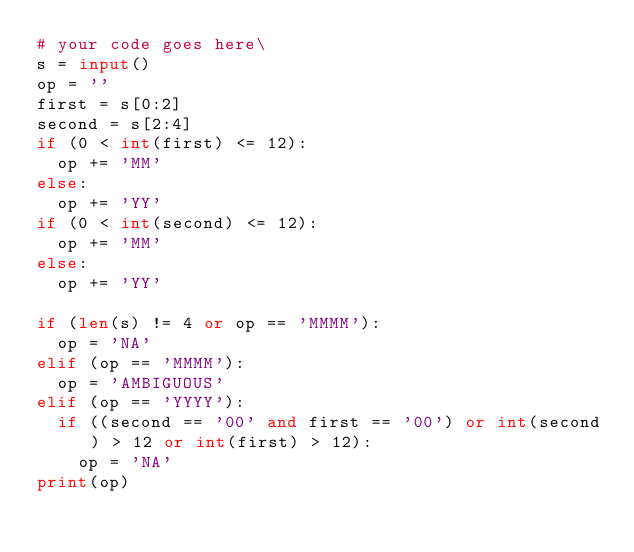Convert code to text. <code><loc_0><loc_0><loc_500><loc_500><_Python_># your code goes here\
s = input()
op = ''
first = s[0:2]
second = s[2:4]
if (0 < int(first) <= 12):
	op += 'MM'
else:
	op += 'YY'
if (0 < int(second) <= 12):
	op += 'MM'
else:
	op += 'YY'

if (len(s) != 4 or op == 'MMMM'):
	op = 'NA'
elif (op == 'MMMM'):
	op = 'AMBIGUOUS'
elif (op == 'YYYY'):
	if ((second == '00' and first == '00') or int(second) > 12 or int(first) > 12):
		op = 'NA'
print(op)
	
</code> 